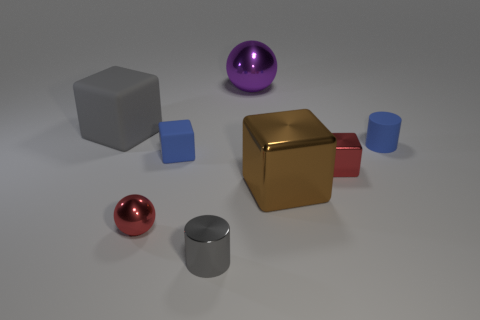Subtract all green cubes. Subtract all blue spheres. How many cubes are left? 4 Add 1 tiny cylinders. How many objects exist? 9 Subtract all spheres. How many objects are left? 6 Add 4 large brown rubber balls. How many large brown rubber balls exist? 4 Subtract 0 blue balls. How many objects are left? 8 Subtract all purple metallic things. Subtract all small gray metal cylinders. How many objects are left? 6 Add 7 metal spheres. How many metal spheres are left? 9 